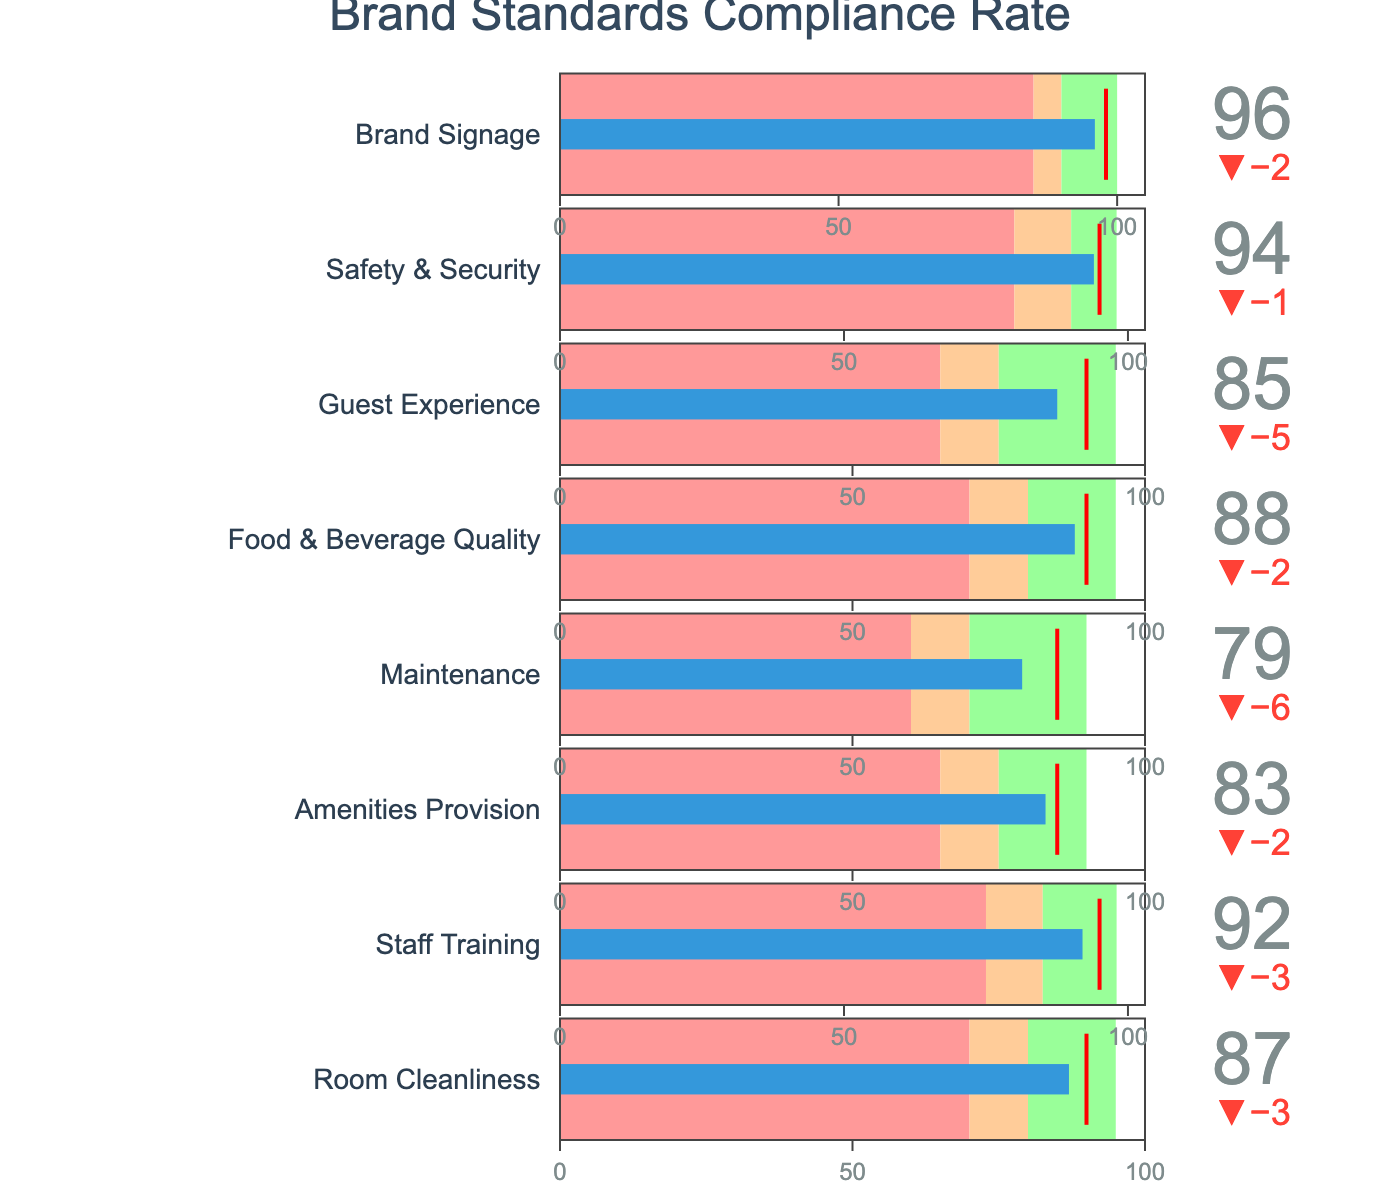What is the title of the figure? The title is usually placed at the top of the figure and can be easily read. For this figure, it reads "Brand Standards Compliance Rate".
Answer: Brand Standards Compliance Rate Which category has the highest actual compliance rate? To find the category with the highest actual compliance rate, look down the "Actual" column and identify the category with the highest value.
Answer: Brand Signage What was the target compliance rate for Staff Training, and how does it compare to the actual rate? The target compliance rate for Staff Training is 95, while the actual compliance rate is 92. To compare them, note that the actual is 3 points below the target.
Answer: Target: 95, Actual: 92 (3 points below) How many categories have an actual compliance rate above 90? Check the "Actual" column and count the number of categories with values above 90. Room Cleanliness, Staff Training, Food & Beverage Quality, Safety & Security, and Brand Signage are above 90.
Answer: 5 categories Are there any categories where the actual compliance rate meets or exceeds the "Good" threshold? If yes, name them. Compare the "Actual" compliance rate with the "Good" threshold in the respective rows. The only category meeting or exceeding the "Good" threshold is Brand Signage.
Answer: Yes, Brand Signage Which category shows the largest negative delta between the actual and target compliance rates? Calculate the difference between the actual and target compliance rates for each category. The category with the largest negative difference is Maintenance (target 85, actual 79) with a delta of -6.
Answer: Maintenance Which categories fall within the "Poor" compliance rate range? Look at the "Poor" range for each category and compare it to the "Actual" rate. If the actual falls within this range, categorize it as "Poor". No categories fall within the poor range.
Answer: None Between Staff Training and Safety & Security, which one has a higher actual compliance rate and by how much? Compare the actual rates of Staff Training (92) and Safety & Security (94). Safety & Security is higher by 2 points.
Answer: Safety & Security by 2 points What is the color used for the "Satisfactory" compliance range in the bullet charts? The color for the "Satisfactory" range is commonly depicted in a distinct color, often identified in the legend or directly in the range bars. For this chart, the color is a light orange or "peach" (#ffcc99).
Answer: Light orange/peach How many categories have their actual compliance rates falling in the "Satisfactory" range? Compare the "Actual" compliance rates against the "Satisfactory" ranges provided. Room Cleanliness, Amenities Provision, Guest Experience, and Maintenance fall within "Satisfactory".
Answer: 4 categories 